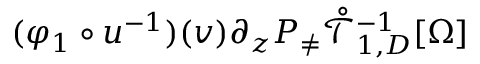Convert formula to latex. <formula><loc_0><loc_0><loc_500><loc_500>( \varphi _ { 1 } \circ u ^ { - 1 } ) ( v ) \partial _ { z } P _ { \neq } \mathring { \mathcal { T } } _ { 1 , D } ^ { - 1 } [ \Omega ]</formula> 